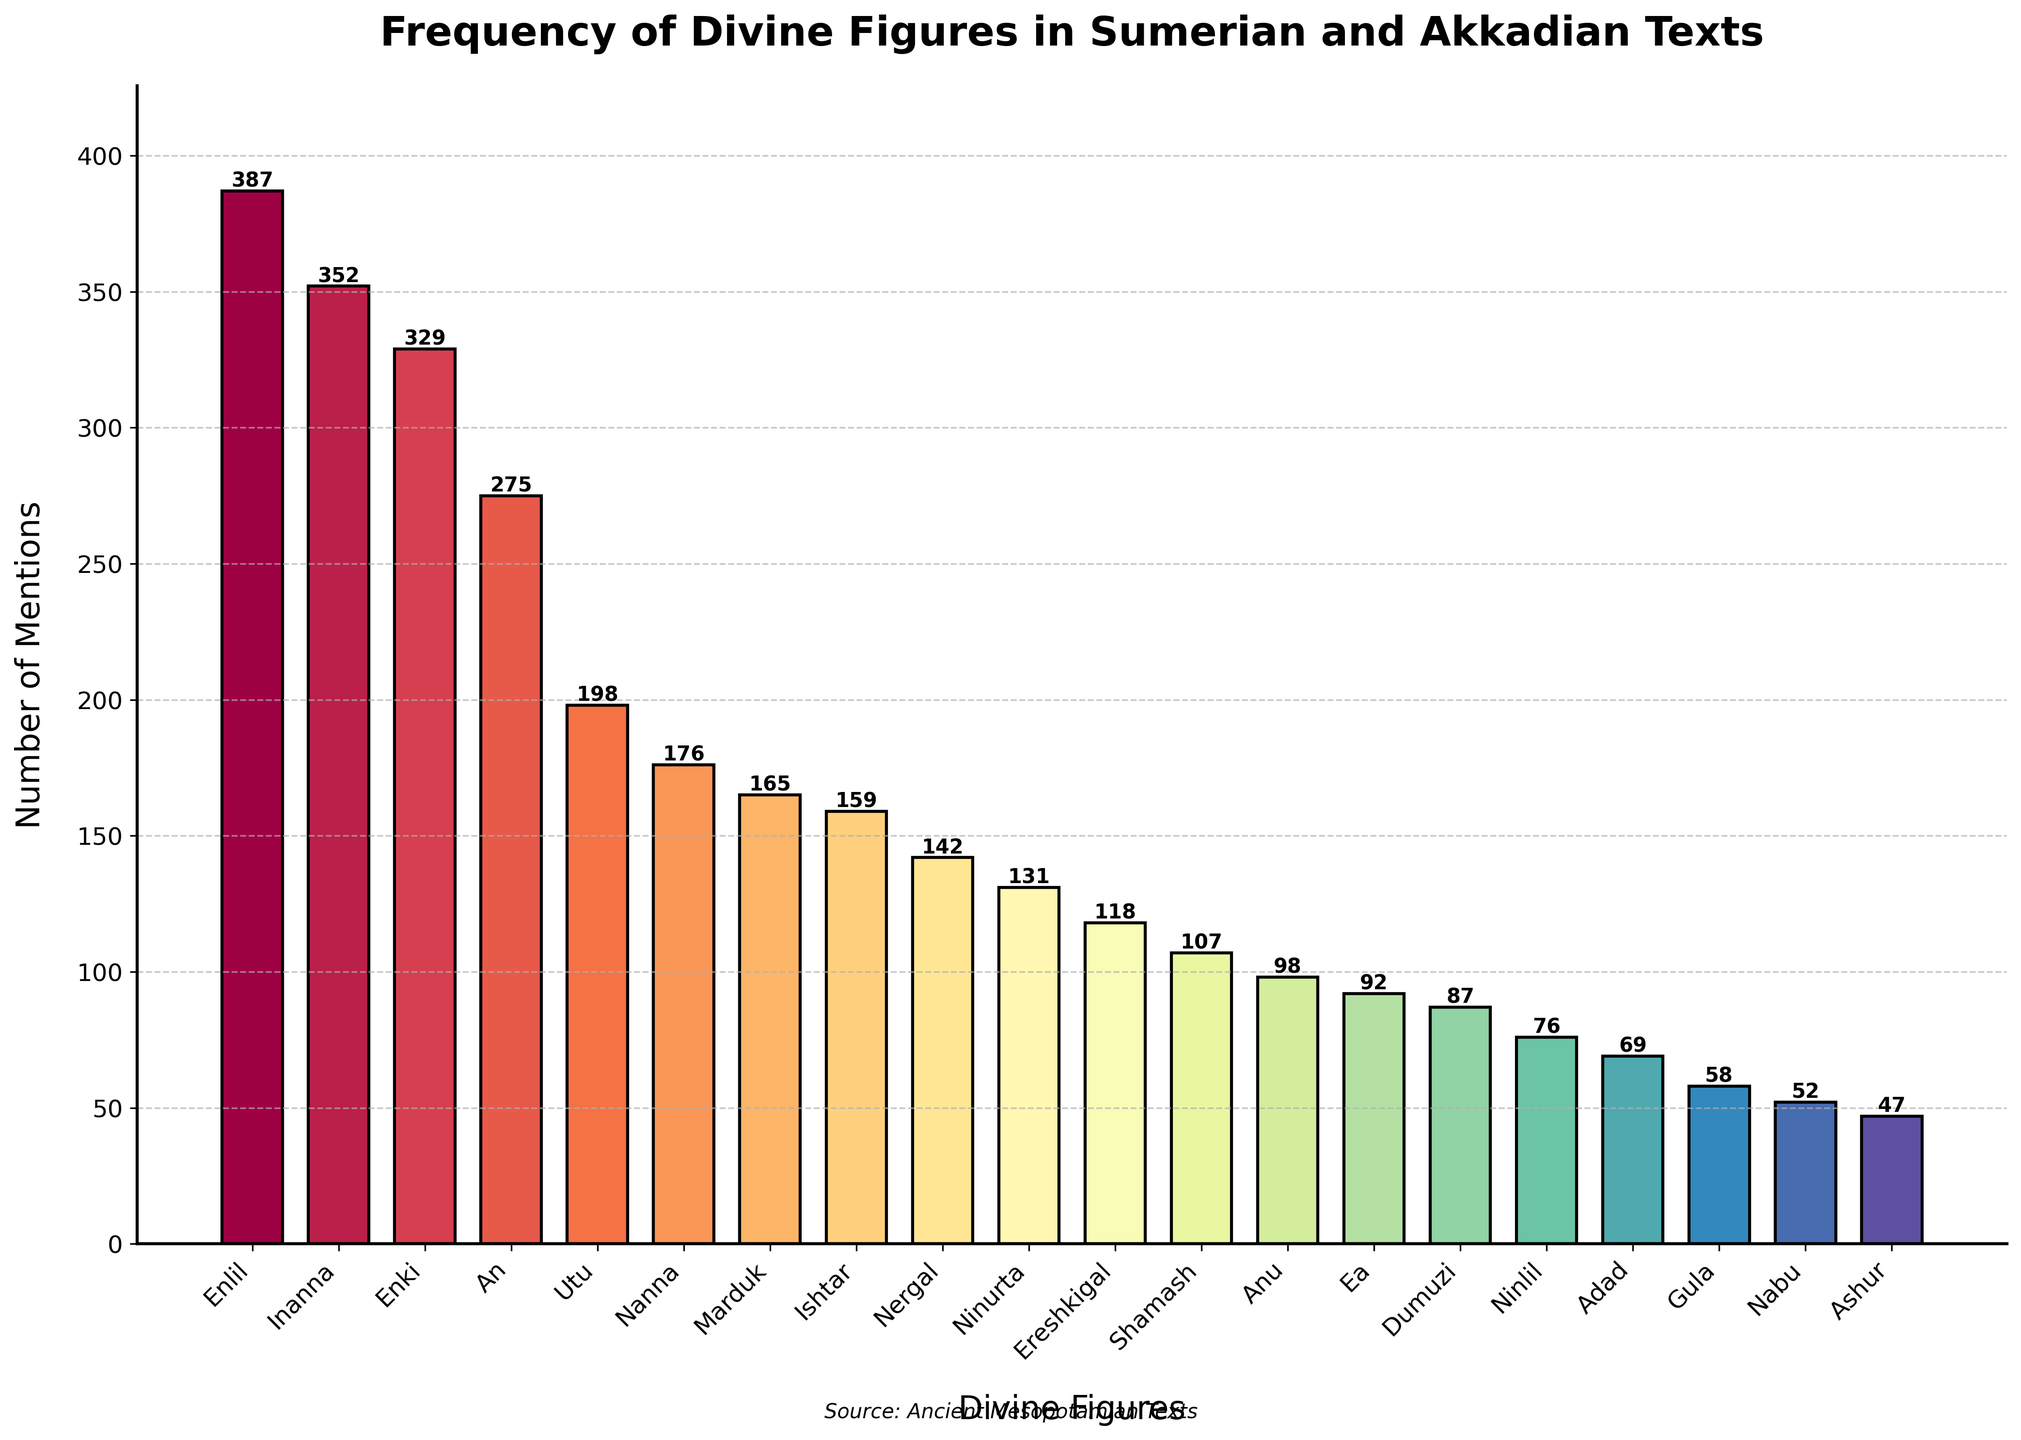What are the three most mentioned divine figures in the texts? To find the three most mentioned divine figures, look for the three bars representing the highest values on the y-axis. The highest bars correspond to Enlil, Inanna, and Enki.
Answer: Enlil, Inanna, Enki How many mentions separate Enlil and Anu? First, identify the heights of the bars corresponding to Enlil and Anu. Enlil has 387 mentions, and Anu has 98 mentions. Subtract Anu's mentions from Enlil's mentions: 387 - 98 = 289.
Answer: 289 Which divine figure has approximately half as many mentions as Enlil? Enlil has 387 mentions. Half of this is roughly 387 / 2 = 193. Look for a bar close to this height. Utu has 198 mentions, which is approximately half of Enlil's mentions.
Answer: Utu What is the combined number of mentions for Inanna and Enki? Find the number of mentions for Inanna and Enki in the chart. Inanna has 352 mentions, and Enki has 329 mentions. Add these together: 352 + 329 = 681.
Answer: 681 Who has fewer mentions, Nergal or Ninurta? Compare the heights of the bars for Nergal and Ninurta. Nergal has 142 mentions, and Ninurta has 131 mentions. Ninurta has fewer mentions.
Answer: Ninurta What is the average number of mentions for the top five most mentioned divine figures? Identify the top five most mentioned figures by looking at the highest bars: Enlil (387), Inanna (352), Enki (329), An (275), and Utu (198). Add these values: 387 + 352 + 329 + 275 + 198 = 1541. Divide this sum by 5 to get the average: 1541 / 5 = 308.2.
Answer: 308.2 How does the number of mentions for Ishtar compare to Nanna? Refer to the chart for mentions of Ishtar and Nanna. Ishtar has 159 mentions, and Nanna has 176 mentions. Nanna has more mentions than Ishtar.
Answer: Nanna has more What is the total number of mentions for figures mentioned fewer than 100 times? Identify figures with fewer than 100 mentions: Anu (98), Ea (92), Dumuzi (87), Ninlil (76), Adad (69), Gula (58), Nabu (52), Ashur (47). Sum these values: 98 + 92 + 87 + 76 + 69 + 58 + 52 + 47 = 579.
Answer: 579 Which bar's color transitions from a warmer hue to a cooler one? Observe the color gradient from warmer to cooler hues (e.g., red to blue). Identify the bar where this transition occurs. This bar is likely in the middle of the chart. The color of this bar is typically around the figures like Utu or Nanna due to the color mapping.
Answer: Utu or Nanna Who is more frequently mentioned, Ereshkigal or Marduk? Compare the heights of the bars for Ereshkigal and Marduk. Ereshkigal has 118 mentions, and Marduk has 165 mentions. Marduk is more frequently mentioned.
Answer: Marduk 